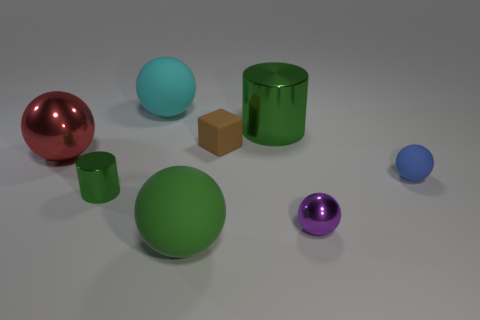Subtract all red spheres. How many spheres are left? 4 Subtract all green rubber balls. How many balls are left? 4 Add 2 shiny things. How many objects exist? 10 Subtract all red balls. Subtract all yellow cylinders. How many balls are left? 4 Subtract all blocks. How many objects are left? 7 Add 5 small blue objects. How many small blue objects are left? 6 Add 6 green metallic cylinders. How many green metallic cylinders exist? 8 Subtract 1 blue balls. How many objects are left? 7 Subtract all tiny cyan rubber blocks. Subtract all brown cubes. How many objects are left? 7 